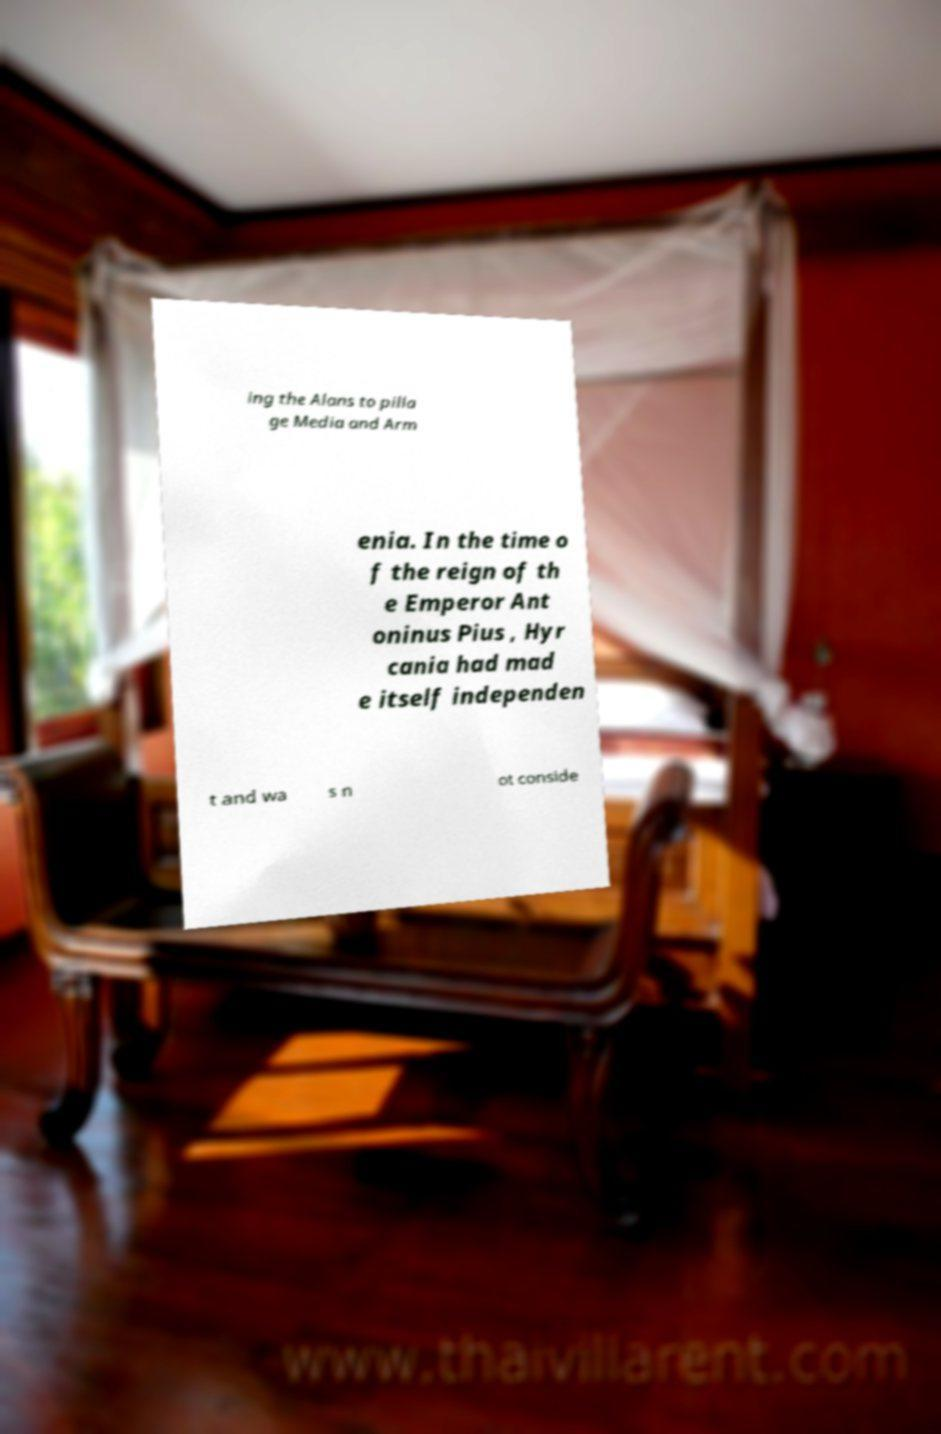Please read and relay the text visible in this image. What does it say? ing the Alans to pilla ge Media and Arm enia. In the time o f the reign of th e Emperor Ant oninus Pius , Hyr cania had mad e itself independen t and wa s n ot conside 